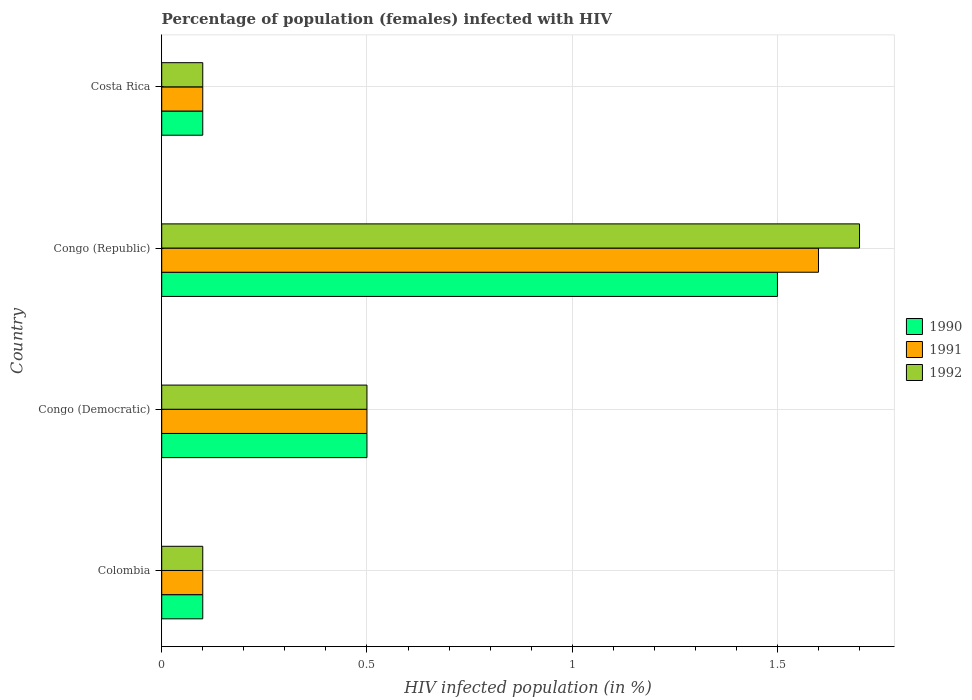How many different coloured bars are there?
Make the answer very short. 3. Are the number of bars per tick equal to the number of legend labels?
Provide a succinct answer. Yes. What is the label of the 3rd group of bars from the top?
Provide a succinct answer. Congo (Democratic). In how many cases, is the number of bars for a given country not equal to the number of legend labels?
Offer a terse response. 0. Across all countries, what is the maximum percentage of HIV infected female population in 1990?
Make the answer very short. 1.5. Across all countries, what is the minimum percentage of HIV infected female population in 1992?
Your answer should be very brief. 0.1. In which country was the percentage of HIV infected female population in 1990 maximum?
Provide a succinct answer. Congo (Republic). In which country was the percentage of HIV infected female population in 1992 minimum?
Offer a very short reply. Colombia. What is the difference between the percentage of HIV infected female population in 1990 in Colombia and that in Congo (Republic)?
Provide a short and direct response. -1.4. What is the difference between the percentage of HIV infected female population in 1992 in Congo (Republic) and the percentage of HIV infected female population in 1990 in Colombia?
Provide a succinct answer. 1.6. What is the difference between the highest and the second highest percentage of HIV infected female population in 1992?
Provide a short and direct response. 1.2. Is the sum of the percentage of HIV infected female population in 1990 in Colombia and Costa Rica greater than the maximum percentage of HIV infected female population in 1991 across all countries?
Make the answer very short. No. How many bars are there?
Offer a terse response. 12. Are all the bars in the graph horizontal?
Provide a short and direct response. Yes. What is the difference between two consecutive major ticks on the X-axis?
Make the answer very short. 0.5. Are the values on the major ticks of X-axis written in scientific E-notation?
Offer a terse response. No. Does the graph contain grids?
Keep it short and to the point. Yes. Where does the legend appear in the graph?
Keep it short and to the point. Center right. How are the legend labels stacked?
Offer a terse response. Vertical. What is the title of the graph?
Provide a succinct answer. Percentage of population (females) infected with HIV. What is the label or title of the X-axis?
Provide a succinct answer. HIV infected population (in %). What is the HIV infected population (in %) in 1990 in Colombia?
Provide a short and direct response. 0.1. What is the HIV infected population (in %) of 1992 in Colombia?
Keep it short and to the point. 0.1. What is the HIV infected population (in %) in 1990 in Congo (Republic)?
Keep it short and to the point. 1.5. What is the HIV infected population (in %) in 1991 in Congo (Republic)?
Keep it short and to the point. 1.6. What is the HIV infected population (in %) in 1990 in Costa Rica?
Your answer should be very brief. 0.1. Across all countries, what is the minimum HIV infected population (in %) in 1990?
Ensure brevity in your answer.  0.1. Across all countries, what is the minimum HIV infected population (in %) of 1992?
Your answer should be compact. 0.1. What is the total HIV infected population (in %) in 1992 in the graph?
Your answer should be very brief. 2.4. What is the difference between the HIV infected population (in %) of 1990 in Colombia and that in Congo (Democratic)?
Your answer should be compact. -0.4. What is the difference between the HIV infected population (in %) in 1991 in Colombia and that in Congo (Democratic)?
Ensure brevity in your answer.  -0.4. What is the difference between the HIV infected population (in %) in 1991 in Colombia and that in Congo (Republic)?
Your response must be concise. -1.5. What is the difference between the HIV infected population (in %) in 1990 in Colombia and that in Costa Rica?
Provide a succinct answer. 0. What is the difference between the HIV infected population (in %) in 1991 in Colombia and that in Costa Rica?
Ensure brevity in your answer.  0. What is the difference between the HIV infected population (in %) of 1992 in Colombia and that in Costa Rica?
Your response must be concise. 0. What is the difference between the HIV infected population (in %) of 1990 in Congo (Democratic) and that in Congo (Republic)?
Offer a very short reply. -1. What is the difference between the HIV infected population (in %) in 1991 in Congo (Democratic) and that in Costa Rica?
Offer a terse response. 0.4. What is the difference between the HIV infected population (in %) of 1991 in Congo (Republic) and that in Costa Rica?
Your answer should be compact. 1.5. What is the difference between the HIV infected population (in %) of 1990 in Colombia and the HIV infected population (in %) of 1991 in Congo (Democratic)?
Give a very brief answer. -0.4. What is the difference between the HIV infected population (in %) in 1990 in Colombia and the HIV infected population (in %) in 1991 in Congo (Republic)?
Your answer should be compact. -1.5. What is the difference between the HIV infected population (in %) of 1990 in Colombia and the HIV infected population (in %) of 1992 in Congo (Republic)?
Provide a succinct answer. -1.6. What is the difference between the HIV infected population (in %) of 1990 in Colombia and the HIV infected population (in %) of 1992 in Costa Rica?
Provide a short and direct response. 0. What is the difference between the HIV infected population (in %) of 1991 in Congo (Democratic) and the HIV infected population (in %) of 1992 in Congo (Republic)?
Offer a very short reply. -1.2. What is the difference between the HIV infected population (in %) in 1990 in Congo (Republic) and the HIV infected population (in %) in 1991 in Costa Rica?
Make the answer very short. 1.4. What is the difference between the HIV infected population (in %) of 1990 in Congo (Republic) and the HIV infected population (in %) of 1992 in Costa Rica?
Give a very brief answer. 1.4. What is the difference between the HIV infected population (in %) in 1991 in Congo (Republic) and the HIV infected population (in %) in 1992 in Costa Rica?
Keep it short and to the point. 1.5. What is the average HIV infected population (in %) in 1990 per country?
Give a very brief answer. 0.55. What is the average HIV infected population (in %) of 1991 per country?
Give a very brief answer. 0.57. What is the average HIV infected population (in %) in 1992 per country?
Your answer should be very brief. 0.6. What is the difference between the HIV infected population (in %) in 1991 and HIV infected population (in %) in 1992 in Congo (Democratic)?
Your response must be concise. 0. What is the difference between the HIV infected population (in %) in 1990 and HIV infected population (in %) in 1991 in Congo (Republic)?
Provide a succinct answer. -0.1. What is the difference between the HIV infected population (in %) in 1990 and HIV infected population (in %) in 1992 in Congo (Republic)?
Your response must be concise. -0.2. What is the difference between the HIV infected population (in %) of 1991 and HIV infected population (in %) of 1992 in Congo (Republic)?
Keep it short and to the point. -0.1. What is the ratio of the HIV infected population (in %) in 1990 in Colombia to that in Congo (Democratic)?
Your answer should be compact. 0.2. What is the ratio of the HIV infected population (in %) of 1991 in Colombia to that in Congo (Democratic)?
Your answer should be compact. 0.2. What is the ratio of the HIV infected population (in %) of 1992 in Colombia to that in Congo (Democratic)?
Give a very brief answer. 0.2. What is the ratio of the HIV infected population (in %) in 1990 in Colombia to that in Congo (Republic)?
Your answer should be very brief. 0.07. What is the ratio of the HIV infected population (in %) in 1991 in Colombia to that in Congo (Republic)?
Provide a short and direct response. 0.06. What is the ratio of the HIV infected population (in %) of 1992 in Colombia to that in Congo (Republic)?
Make the answer very short. 0.06. What is the ratio of the HIV infected population (in %) of 1990 in Colombia to that in Costa Rica?
Your answer should be very brief. 1. What is the ratio of the HIV infected population (in %) in 1992 in Colombia to that in Costa Rica?
Your answer should be compact. 1. What is the ratio of the HIV infected population (in %) of 1990 in Congo (Democratic) to that in Congo (Republic)?
Offer a very short reply. 0.33. What is the ratio of the HIV infected population (in %) of 1991 in Congo (Democratic) to that in Congo (Republic)?
Make the answer very short. 0.31. What is the ratio of the HIV infected population (in %) of 1992 in Congo (Democratic) to that in Congo (Republic)?
Provide a short and direct response. 0.29. What is the ratio of the HIV infected population (in %) in 1990 in Congo (Democratic) to that in Costa Rica?
Your answer should be very brief. 5. What is the ratio of the HIV infected population (in %) of 1991 in Congo (Democratic) to that in Costa Rica?
Your answer should be very brief. 5. What is the ratio of the HIV infected population (in %) in 1992 in Congo (Democratic) to that in Costa Rica?
Provide a short and direct response. 5. What is the ratio of the HIV infected population (in %) in 1990 in Congo (Republic) to that in Costa Rica?
Offer a terse response. 15. What is the ratio of the HIV infected population (in %) of 1991 in Congo (Republic) to that in Costa Rica?
Provide a succinct answer. 16. What is the ratio of the HIV infected population (in %) in 1992 in Congo (Republic) to that in Costa Rica?
Your response must be concise. 17. What is the difference between the highest and the second highest HIV infected population (in %) in 1991?
Offer a very short reply. 1.1. What is the difference between the highest and the second highest HIV infected population (in %) in 1992?
Provide a succinct answer. 1.2. What is the difference between the highest and the lowest HIV infected population (in %) in 1990?
Keep it short and to the point. 1.4. What is the difference between the highest and the lowest HIV infected population (in %) in 1992?
Provide a succinct answer. 1.6. 